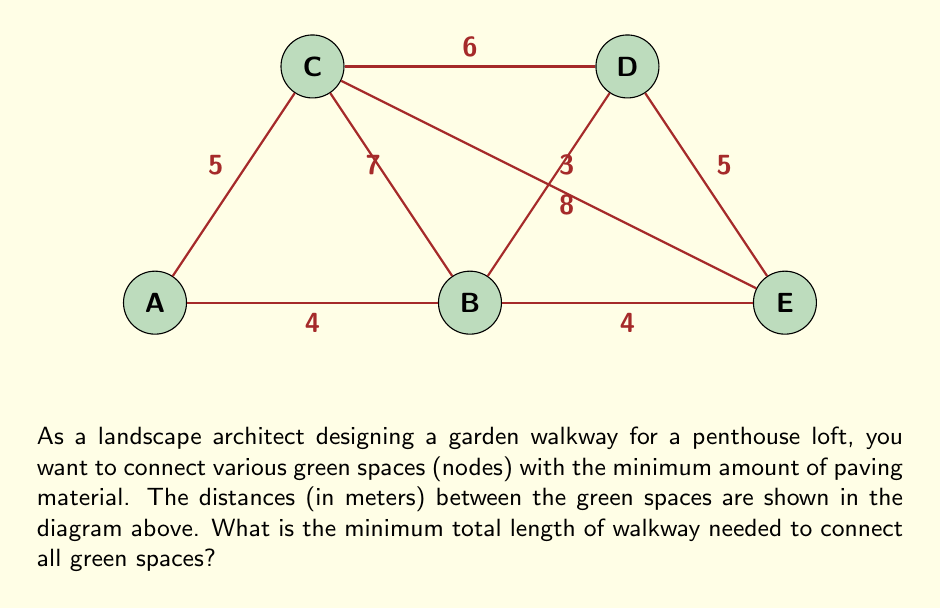What is the answer to this math problem? To find the minimum total length of walkway needed to connect all green spaces, we need to determine the minimum spanning tree of the given graph. We can use Kruskal's algorithm to solve this problem:

1) Sort all edges by weight (distance) in ascending order:
   BD (3), AB (4), BE (4), AC (5), DE (5), CD (6), BC (7), CE (8)

2) Start with an empty set of edges and add edges one by one, skipping any that would create a cycle:

   - Add BD (3)
   - Add AB (4)
   - Add BE (4)
   - Add AC (5)

3) At this point, all nodes are connected, and we have our minimum spanning tree.

4) Calculate the total length of the walkway by summing the lengths of the chosen edges:

   $$3 + 4 + 4 + 5 = 16$$

Therefore, the minimum total length of walkway needed to connect all green spaces is 16 meters.
Answer: 16 meters 